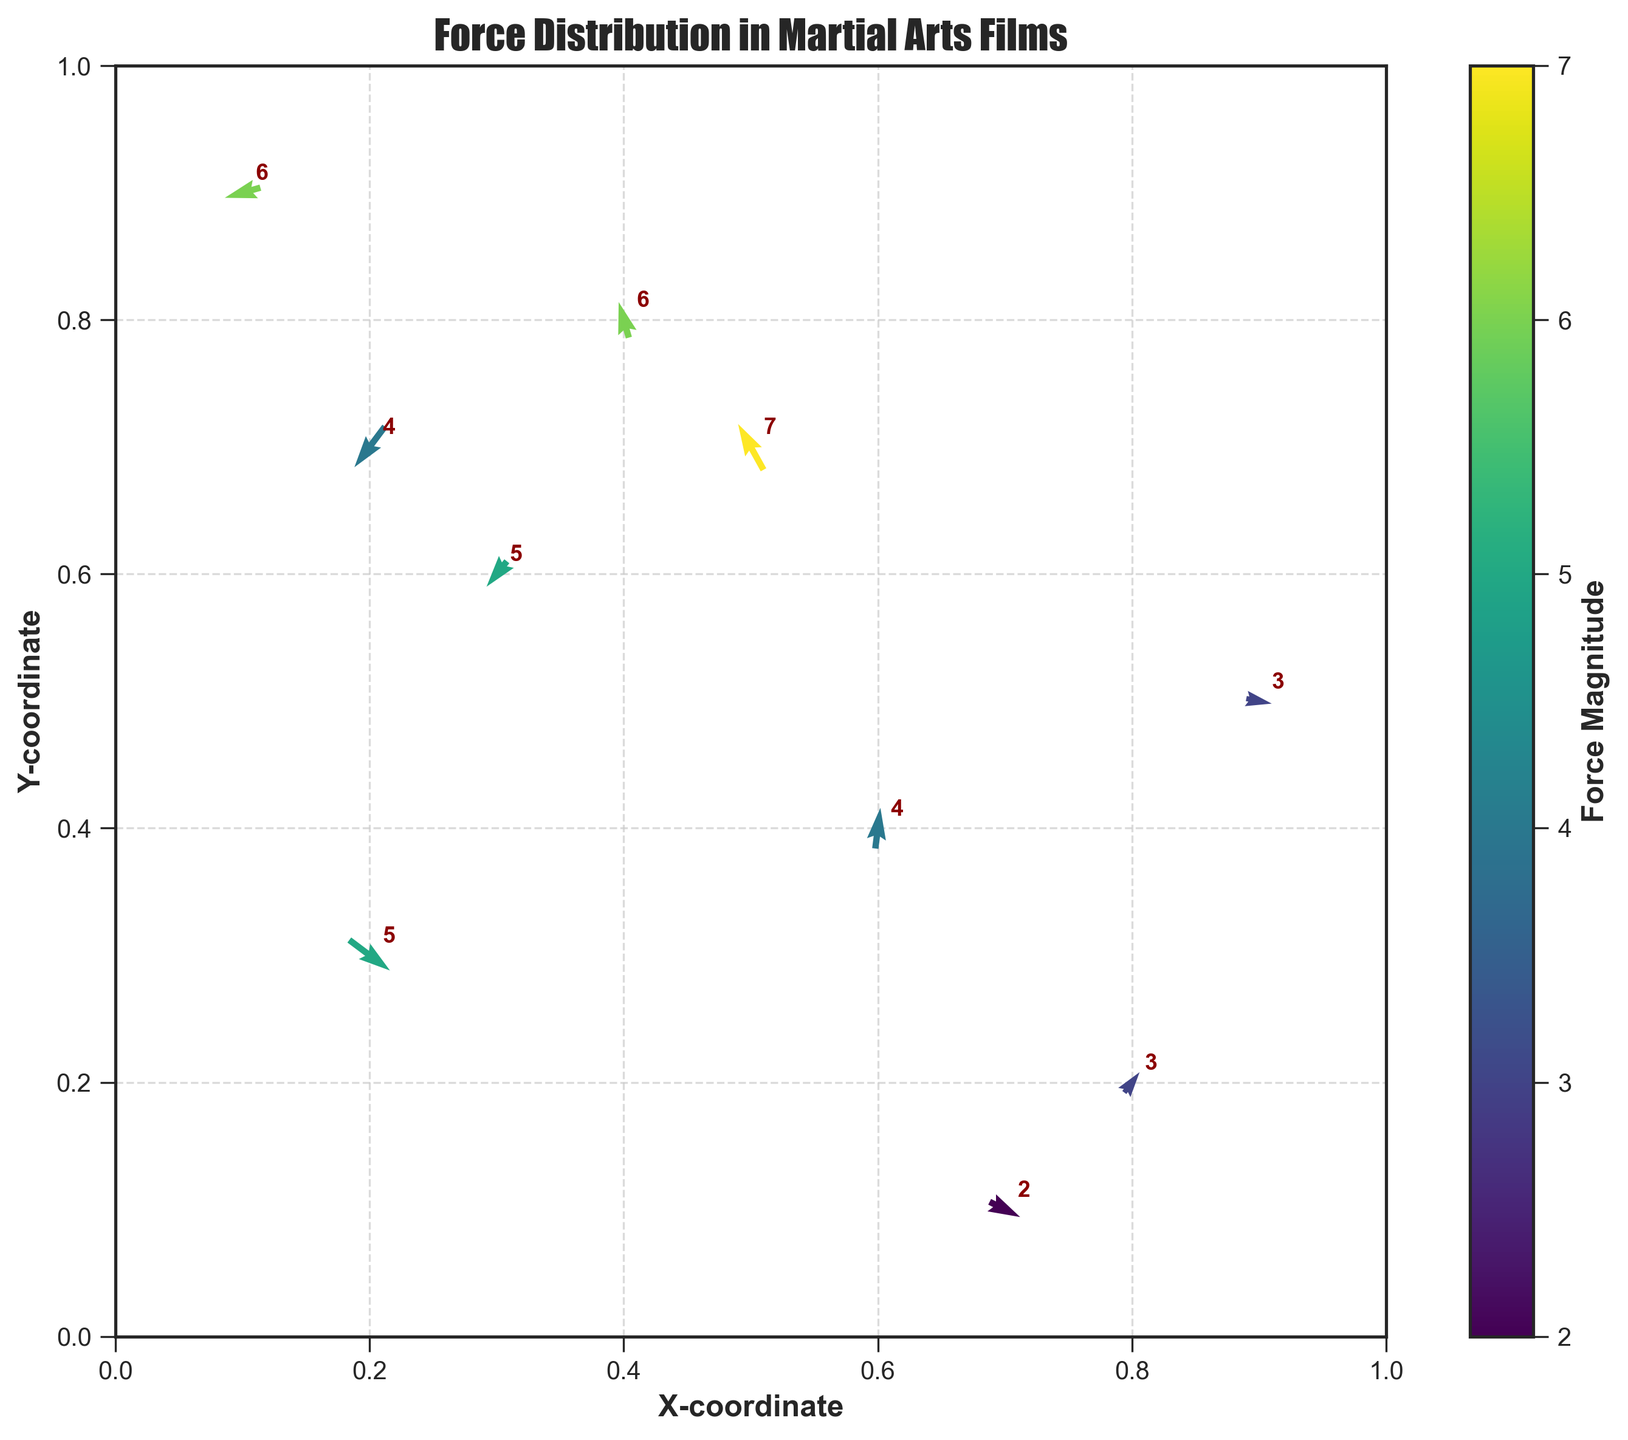what is the title of the plot? The title is displayed at the top of the plot and states the main subject of the figure.
Answer: Force Distribution in Martial Arts Films How many arrows are shown in the plot? Each data point in the dataset is represented by a single arrow. By counting the arrows, we can see how many data points there are.
Answer: 10 What is the color of the arrows representing the highest force magnitude? The arrows' color represents the magnitude of the force, as indicated by the color bar. The highest force magnitude, 7, is colored with the most distinct shade according to the color map.
Answer: The color corresponding to 7 on the color scale What coordinate has the largest force magnitude and what is its value? By looking at the annotated force magnitudes on the plot, the coordinate with the highest value (7) can be identified.
Answer: (0.5, 0.7) and 7 Which arrow shows the largest vertical component of force? The vertical component of force is represented by the 'v' value. The arrow with the largest 'v' value (0.9) can be found at a specific coordinate.
Answer: (0.5, 0.7) Between the coordinates (0.2, 0.3) and (0.8, 0.2), which has a greater magnitude of force? Compare the magnitude of the force at both coordinates by looking at the annotated values. (0.2, 0.3) has a value of 5 and (0.8, 0.2) has a value of 3.
Answer: (0.2, 0.3) What is the difference between the horizontal components of force at coordinates (0.2, 0.3) and (0.1, 0.9)? We subtract the 'u' components of the force at these coordinates: 0.8 (at 0.2, 0.3) - (-0.7 at 0.1, 0.9).
Answer: 1.5 Which arrows have a negative horizontal component of force? Identify the arrows with a negative 'u' value by checking the figure.
Answer: (0.5, 0.7), (0.1, 0.9), (0.3, 0.6), (0.4, 0.8), (0.2, 0.7) Is there any arrow that points downwards? If yes, at which coordinate? Arrows pointing downwards have a negative 'v' value. Locate the arrows with 'v' < 0.
Answer: Yes, at (0.2, 0.3) and (0.7, 0.1) What is the average force magnitude of all data points? Sum all the magnitude values (5 + 7 + 3 + 6 + 4 + 5 + 2 + 6 + 3 + 4), and divide by the number of data points (10).
Answer: 4.5 